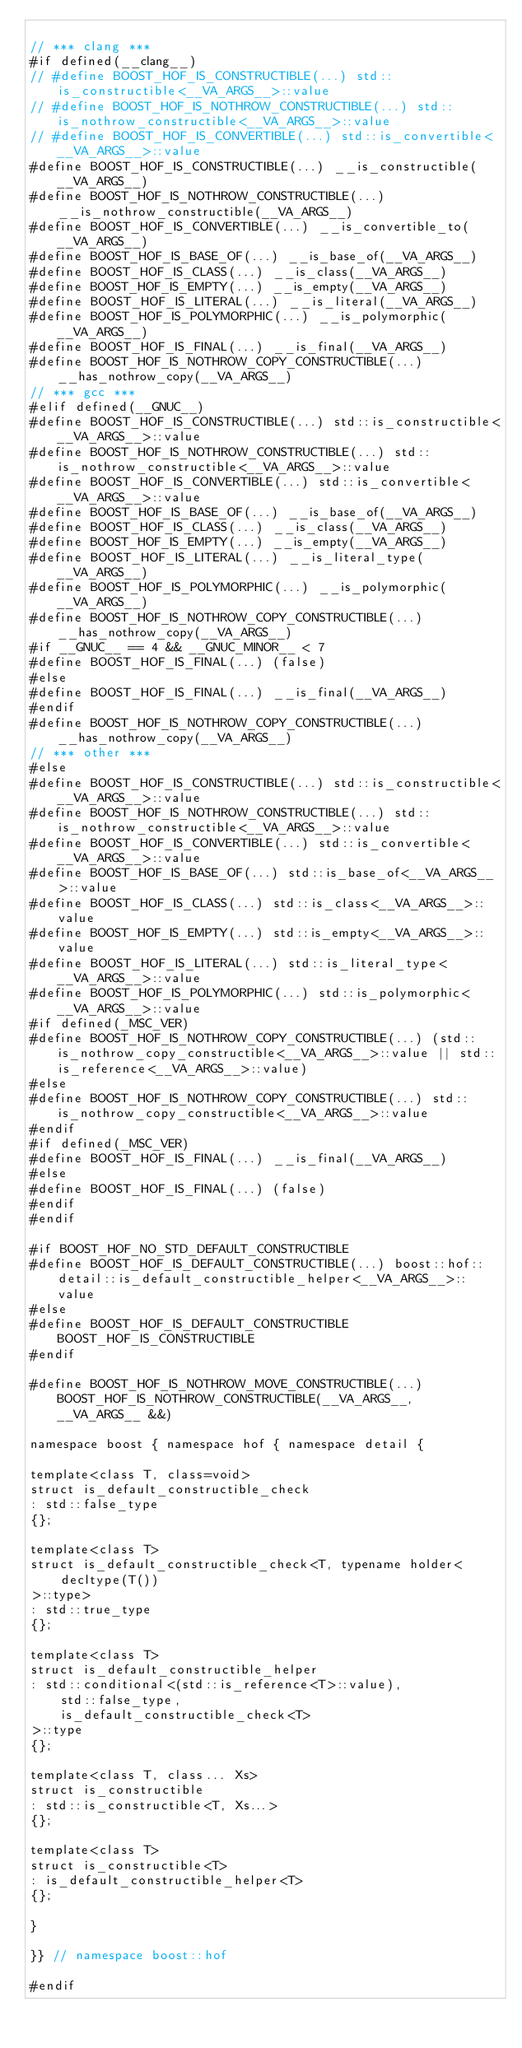<code> <loc_0><loc_0><loc_500><loc_500><_C++_>
// *** clang ***
#if defined(__clang__)
// #define BOOST_HOF_IS_CONSTRUCTIBLE(...) std::is_constructible<__VA_ARGS__>::value
// #define BOOST_HOF_IS_NOTHROW_CONSTRUCTIBLE(...) std::is_nothrow_constructible<__VA_ARGS__>::value
// #define BOOST_HOF_IS_CONVERTIBLE(...) std::is_convertible<__VA_ARGS__>::value
#define BOOST_HOF_IS_CONSTRUCTIBLE(...) __is_constructible(__VA_ARGS__)
#define BOOST_HOF_IS_NOTHROW_CONSTRUCTIBLE(...) __is_nothrow_constructible(__VA_ARGS__)
#define BOOST_HOF_IS_CONVERTIBLE(...) __is_convertible_to(__VA_ARGS__)
#define BOOST_HOF_IS_BASE_OF(...) __is_base_of(__VA_ARGS__)
#define BOOST_HOF_IS_CLASS(...) __is_class(__VA_ARGS__)
#define BOOST_HOF_IS_EMPTY(...) __is_empty(__VA_ARGS__)
#define BOOST_HOF_IS_LITERAL(...) __is_literal(__VA_ARGS__)
#define BOOST_HOF_IS_POLYMORPHIC(...) __is_polymorphic(__VA_ARGS__)
#define BOOST_HOF_IS_FINAL(...) __is_final(__VA_ARGS__)
#define BOOST_HOF_IS_NOTHROW_COPY_CONSTRUCTIBLE(...) __has_nothrow_copy(__VA_ARGS__)
// *** gcc ***
#elif defined(__GNUC__)
#define BOOST_HOF_IS_CONSTRUCTIBLE(...) std::is_constructible<__VA_ARGS__>::value
#define BOOST_HOF_IS_NOTHROW_CONSTRUCTIBLE(...) std::is_nothrow_constructible<__VA_ARGS__>::value
#define BOOST_HOF_IS_CONVERTIBLE(...) std::is_convertible<__VA_ARGS__>::value
#define BOOST_HOF_IS_BASE_OF(...) __is_base_of(__VA_ARGS__)
#define BOOST_HOF_IS_CLASS(...) __is_class(__VA_ARGS__)
#define BOOST_HOF_IS_EMPTY(...) __is_empty(__VA_ARGS__)
#define BOOST_HOF_IS_LITERAL(...) __is_literal_type(__VA_ARGS__)
#define BOOST_HOF_IS_POLYMORPHIC(...) __is_polymorphic(__VA_ARGS__)
#define BOOST_HOF_IS_NOTHROW_COPY_CONSTRUCTIBLE(...) __has_nothrow_copy(__VA_ARGS__)
#if __GNUC__ == 4 && __GNUC_MINOR__ < 7
#define BOOST_HOF_IS_FINAL(...) (false)
#else
#define BOOST_HOF_IS_FINAL(...) __is_final(__VA_ARGS__)
#endif
#define BOOST_HOF_IS_NOTHROW_COPY_CONSTRUCTIBLE(...) __has_nothrow_copy(__VA_ARGS__)
// *** other ***
#else
#define BOOST_HOF_IS_CONSTRUCTIBLE(...) std::is_constructible<__VA_ARGS__>::value
#define BOOST_HOF_IS_NOTHROW_CONSTRUCTIBLE(...) std::is_nothrow_constructible<__VA_ARGS__>::value
#define BOOST_HOF_IS_CONVERTIBLE(...) std::is_convertible<__VA_ARGS__>::value
#define BOOST_HOF_IS_BASE_OF(...) std::is_base_of<__VA_ARGS__>::value
#define BOOST_HOF_IS_CLASS(...) std::is_class<__VA_ARGS__>::value
#define BOOST_HOF_IS_EMPTY(...) std::is_empty<__VA_ARGS__>::value
#define BOOST_HOF_IS_LITERAL(...) std::is_literal_type<__VA_ARGS__>::value
#define BOOST_HOF_IS_POLYMORPHIC(...) std::is_polymorphic<__VA_ARGS__>::value
#if defined(_MSC_VER)
#define BOOST_HOF_IS_NOTHROW_COPY_CONSTRUCTIBLE(...) (std::is_nothrow_copy_constructible<__VA_ARGS__>::value || std::is_reference<__VA_ARGS__>::value)
#else
#define BOOST_HOF_IS_NOTHROW_COPY_CONSTRUCTIBLE(...) std::is_nothrow_copy_constructible<__VA_ARGS__>::value
#endif
#if defined(_MSC_VER)
#define BOOST_HOF_IS_FINAL(...) __is_final(__VA_ARGS__)
#else
#define BOOST_HOF_IS_FINAL(...) (false)
#endif
#endif

#if BOOST_HOF_NO_STD_DEFAULT_CONSTRUCTIBLE
#define BOOST_HOF_IS_DEFAULT_CONSTRUCTIBLE(...) boost::hof::detail::is_default_constructible_helper<__VA_ARGS__>::value
#else
#define BOOST_HOF_IS_DEFAULT_CONSTRUCTIBLE BOOST_HOF_IS_CONSTRUCTIBLE
#endif

#define BOOST_HOF_IS_NOTHROW_MOVE_CONSTRUCTIBLE(...) BOOST_HOF_IS_NOTHROW_CONSTRUCTIBLE(__VA_ARGS__, __VA_ARGS__ &&)

namespace boost { namespace hof { namespace detail {

template<class T, class=void>
struct is_default_constructible_check
: std::false_type
{};

template<class T>
struct is_default_constructible_check<T, typename holder<
    decltype(T())
>::type>
: std::true_type
{};

template<class T>
struct is_default_constructible_helper
: std::conditional<(std::is_reference<T>::value), 
    std::false_type,
    is_default_constructible_check<T>
>::type
{};

template<class T, class... Xs>
struct is_constructible
: std::is_constructible<T, Xs...>
{};

template<class T>
struct is_constructible<T>
: is_default_constructible_helper<T>
{};

}

}} // namespace boost::hof

#endif
</code> 